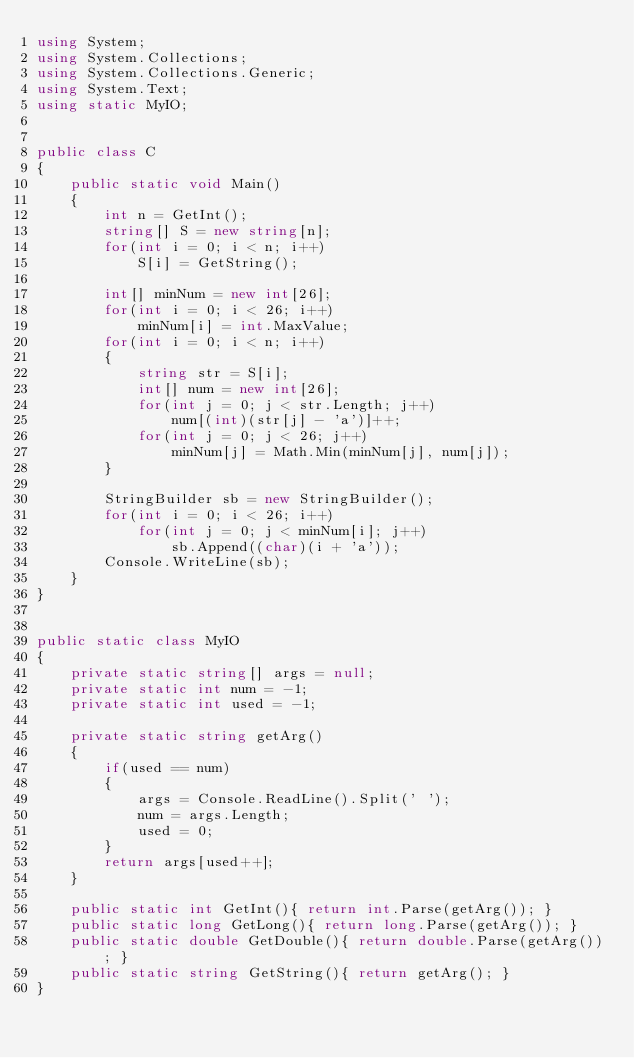<code> <loc_0><loc_0><loc_500><loc_500><_C#_>using System;
using System.Collections;
using System.Collections.Generic;
using System.Text;
using static MyIO;


public class C
{
	public static void Main()	
	{
		int n = GetInt();
		string[] S = new string[n];
		for(int i = 0; i < n; i++)
			S[i] = GetString();
		
		int[] minNum = new int[26];
		for(int i = 0; i < 26; i++)
			minNum[i] = int.MaxValue;
		for(int i = 0; i < n; i++)
		{
			string str = S[i];
			int[] num = new int[26];
			for(int j = 0; j < str.Length; j++)
				num[(int)(str[j] - 'a')]++;
			for(int j = 0; j < 26; j++)
				minNum[j] = Math.Min(minNum[j], num[j]);
		}

		StringBuilder sb = new StringBuilder();
		for(int i = 0; i < 26; i++)
			for(int j = 0; j < minNum[i]; j++)
				sb.Append((char)(i + 'a'));
		Console.WriteLine(sb);
	}
}


public static class MyIO
{
	private static string[] args = null;
	private static int num = -1;
	private static int used = -1;

	private static string getArg()
	{
		if(used == num)
		{
			args = Console.ReadLine().Split(' ');
			num = args.Length;
			used = 0;
		}
		return args[used++];
	}

	public static int GetInt(){ return int.Parse(getArg()); }
	public static long GetLong(){ return long.Parse(getArg()); }
	public static double GetDouble(){ return double.Parse(getArg()); }
	public static string GetString(){ return getArg(); }
}
</code> 